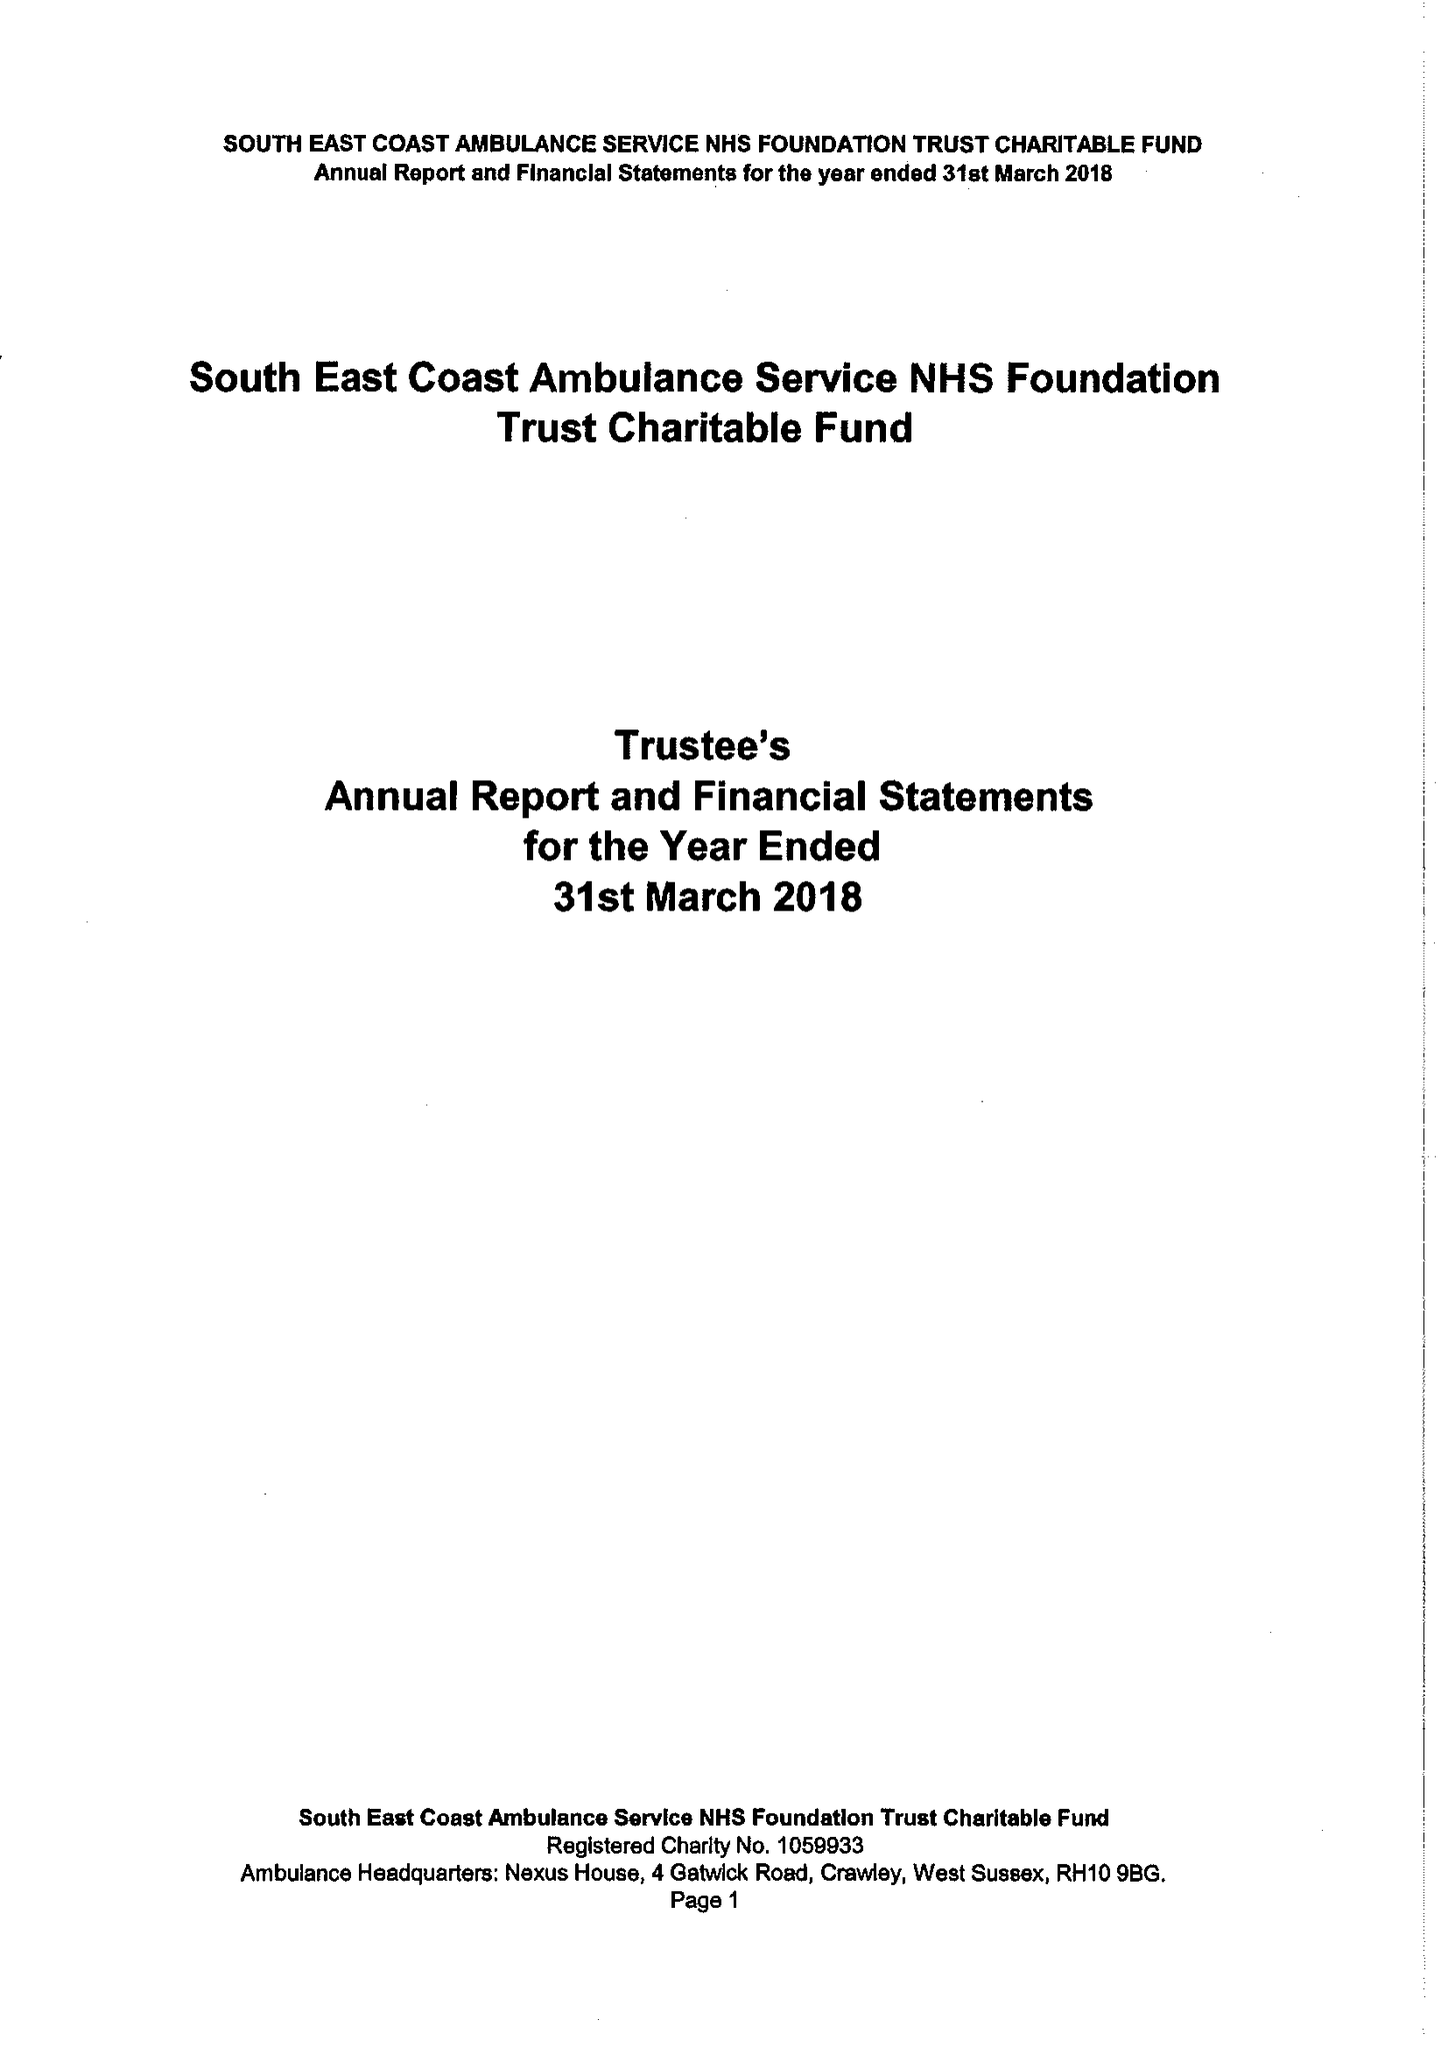What is the value for the report_date?
Answer the question using a single word or phrase. 2018-03-31 